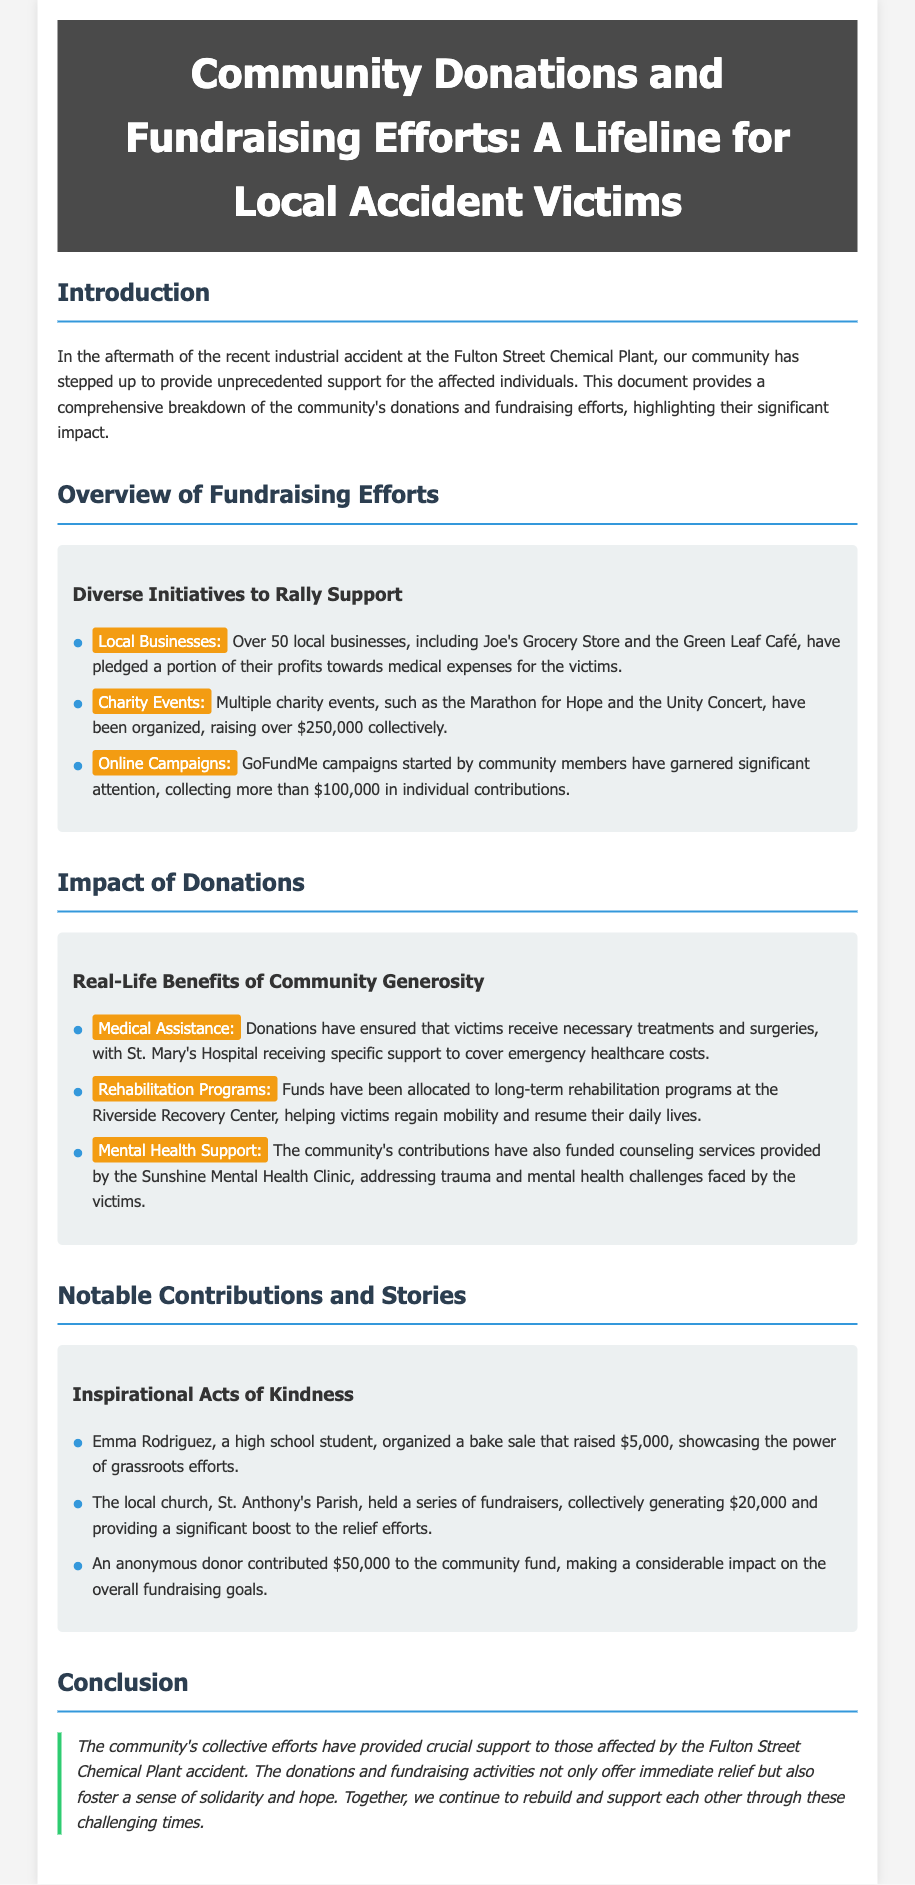What was the total amount raised from charity events? The document mentions that multiple charity events have raised over $250,000 collectively.
Answer: $250,000 How much did GoFundMe campaigns collect? The document states that GoFundMe campaigns started by community members have garnered more than $100,000.
Answer: More than $100,000 Which hospital received specific support for emergency healthcare costs? The document states that St. Mary's Hospital received specific support to cover emergency healthcare costs.
Answer: St. Mary's Hospital Who organized a bake sale that raised $5,000? Emma Rodriguez, a high school student, organized a bake sale that raised $5,000.
Answer: Emma Rodriguez What type of support did the Sunshine Mental Health Clinic provide? Donations funded counseling services provided by the Sunshine Mental Health Clinic.
Answer: Counseling services What is the focus of funds allocated to the Riverside Recovery Center? The document indicates that funds have been allocated to long-term rehabilitation programs helping victims regain mobility.
Answer: Long-term rehabilitation programs How many local businesses pledged support for medical expenses? The document mentions that over 50 local businesses have pledged a portion of their profits towards medical expenses.
Answer: Over 50 What was the impact of the anonymous donor's contribution? An anonymous donor contributed $50,000, making a considerable impact on the overall fundraising goals.
Answer: $50,000 What do the community's efforts represent according to the conclusion? The conclusion states that the community's efforts foster a sense of solidarity and hope.
Answer: Solidarity and hope 